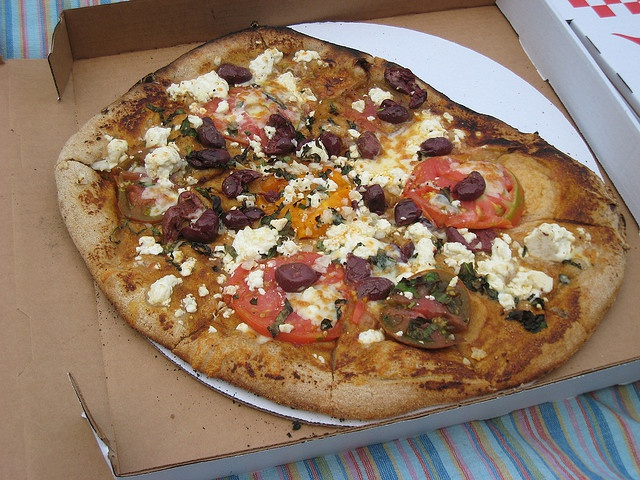Describe the objects in this image and their specific colors. I can see a pizza in gray, brown, maroon, and tan tones in this image. 